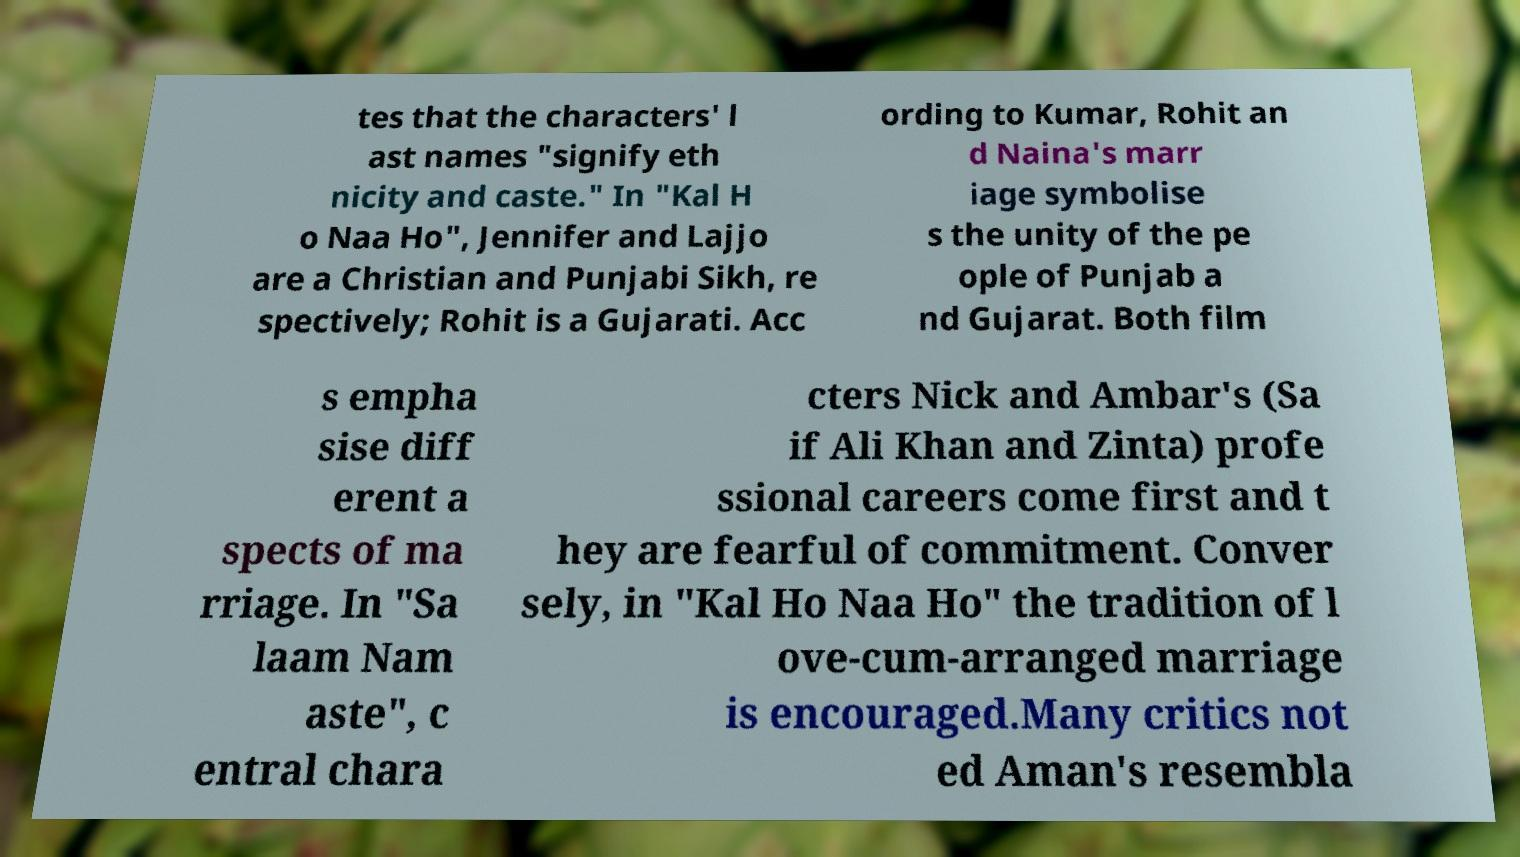Can you accurately transcribe the text from the provided image for me? tes that the characters' l ast names "signify eth nicity and caste." In "Kal H o Naa Ho", Jennifer and Lajjo are a Christian and Punjabi Sikh, re spectively; Rohit is a Gujarati. Acc ording to Kumar, Rohit an d Naina's marr iage symbolise s the unity of the pe ople of Punjab a nd Gujarat. Both film s empha sise diff erent a spects of ma rriage. In "Sa laam Nam aste", c entral chara cters Nick and Ambar's (Sa if Ali Khan and Zinta) profe ssional careers come first and t hey are fearful of commitment. Conver sely, in "Kal Ho Naa Ho" the tradition of l ove-cum-arranged marriage is encouraged.Many critics not ed Aman's resembla 